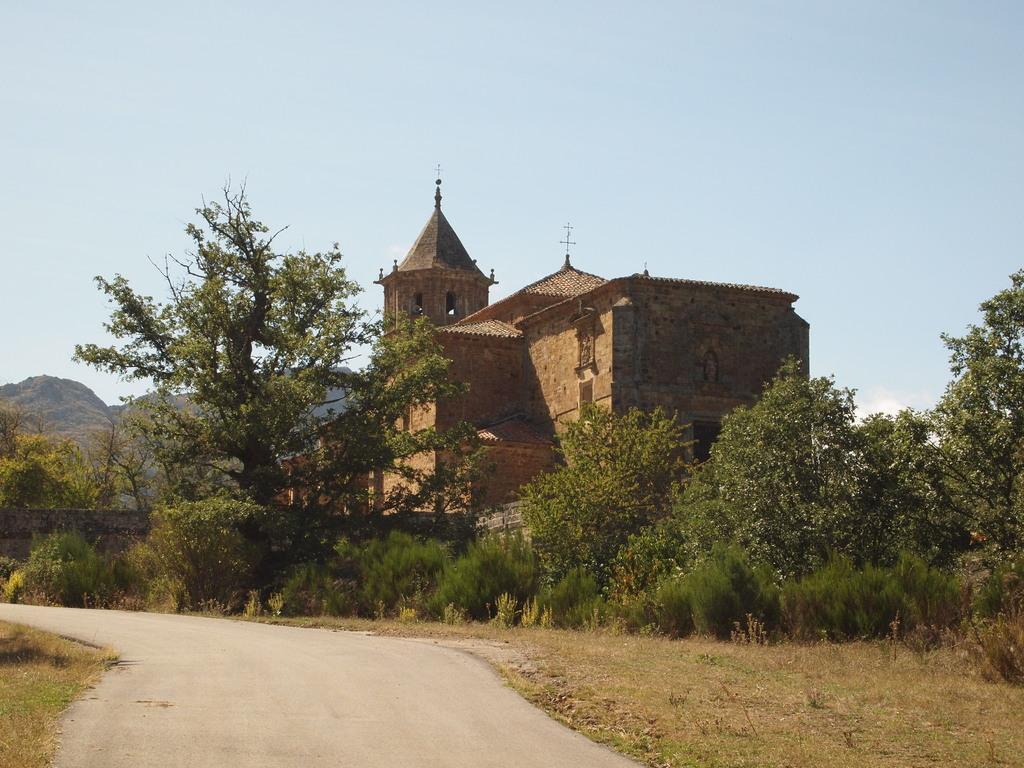Could you give a brief overview of what you see in this image? In the image there is a plain road and around the road there are many plants and trees. Behind the trees there is a building and in the background there are mountains. 